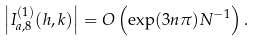<formula> <loc_0><loc_0><loc_500><loc_500>\left | I _ { a , 8 } ^ { ( 1 ) } ( h , k ) \right | = O \left ( \exp ( 3 n \pi ) N ^ { - 1 } \right ) .</formula> 